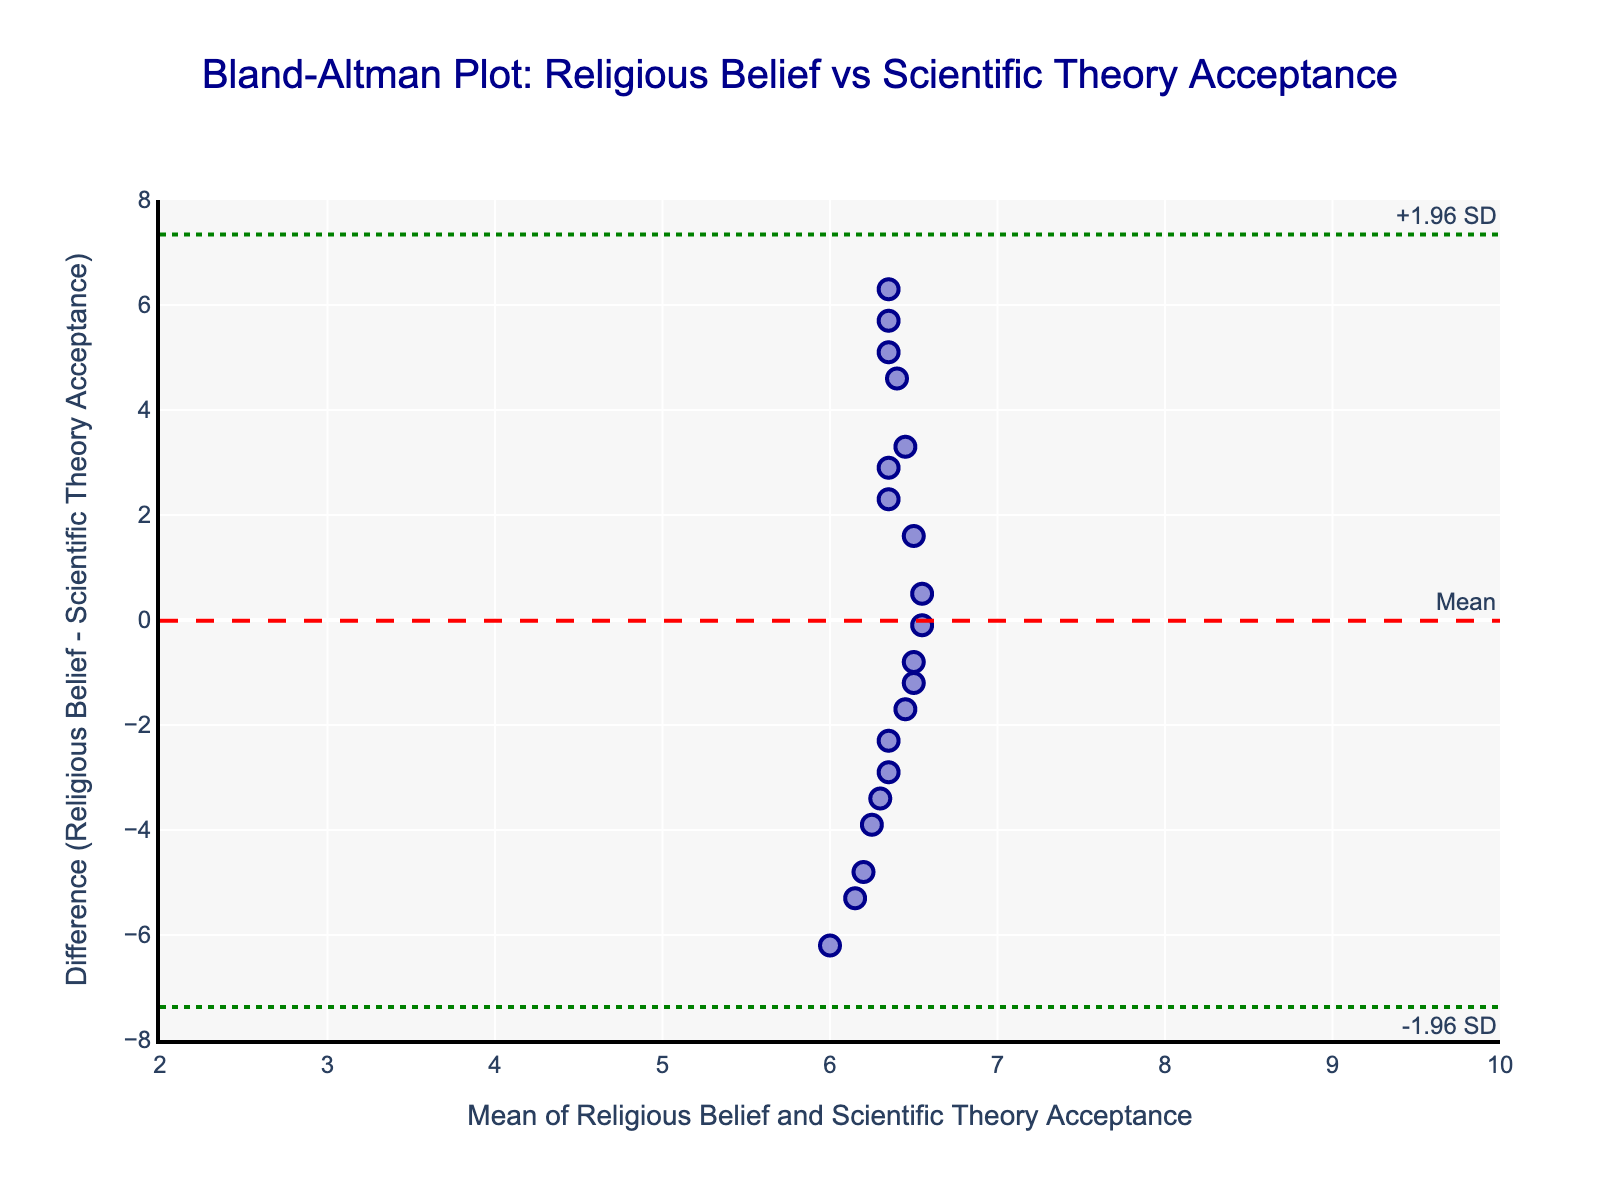What is the title of the figure? The title is usually found at the top of the plot and summarizes what the plot is about. In this case, we look at the center-top of the plot.
Answer: Bland-Altman Plot: Religious Belief vs Scientific Theory Acceptance What are the axis labels and what do they represent? The axis labels are usually positioned along the axes themselves. For the x-axis, it states "Mean of Religious Belief and Scientific Theory Acceptance" which means it shows the average values of both variables. For the y-axis, it states "Difference (Religious Belief - Scientific Theory Acceptance)" which means it shows the difference between the two variables.
Answer: Mean of Religious Belief and Scientific Theory Acceptance (x), Difference (Religious Belief - Scientific Theory Acceptance) (y) How many data points are plotted? Count the number of individual markers (typically dots or points) shown on the plot. Each marker represents one data point.
Answer: 20 What is the color of the data points? Observe the color of all the individual markers plotted on the graph.
Answer: Light blue What is the range of the y-axis? Look at the minimum and maximum values along the y-axis of the plot.
Answer: -8 to 8 What is the mean difference value? Find the red dashed horizontal line on the plot, which is usually annotated as "Mean". The value of this line is the mean difference.
Answer: Approximately 2 What are the limits of agreement values? Find the two green dotted horizontal lines, often annotated as "-1.96 SD" and "+1.96 SD". These are the limits of agreement.
Answer: Approximately 0 and 4 Is there any trend visible in the data points' spread between the mean and limits of agreement? Observe the distribution of the data points between the green dotted lines (limits of agreement). Check if there appears to be any systematic pattern or it looks random.
Answer: Random distribution, no clear trend What does it mean when a data point lies outside the limits of agreement? In a Bland-Altman plot, points outside the limits of agreement indicate potential outliers or significant disagreement in measurements.
Answer: Outliers or significant disagreement Based on this plot, how well do religious belief strength and scientific theory acceptance agree? Interpret the spread of data points around the mean difference and between limits of agreement. If most points lie close to the mean and within limits, there is good agreement.
Answer: Moderate agreement 